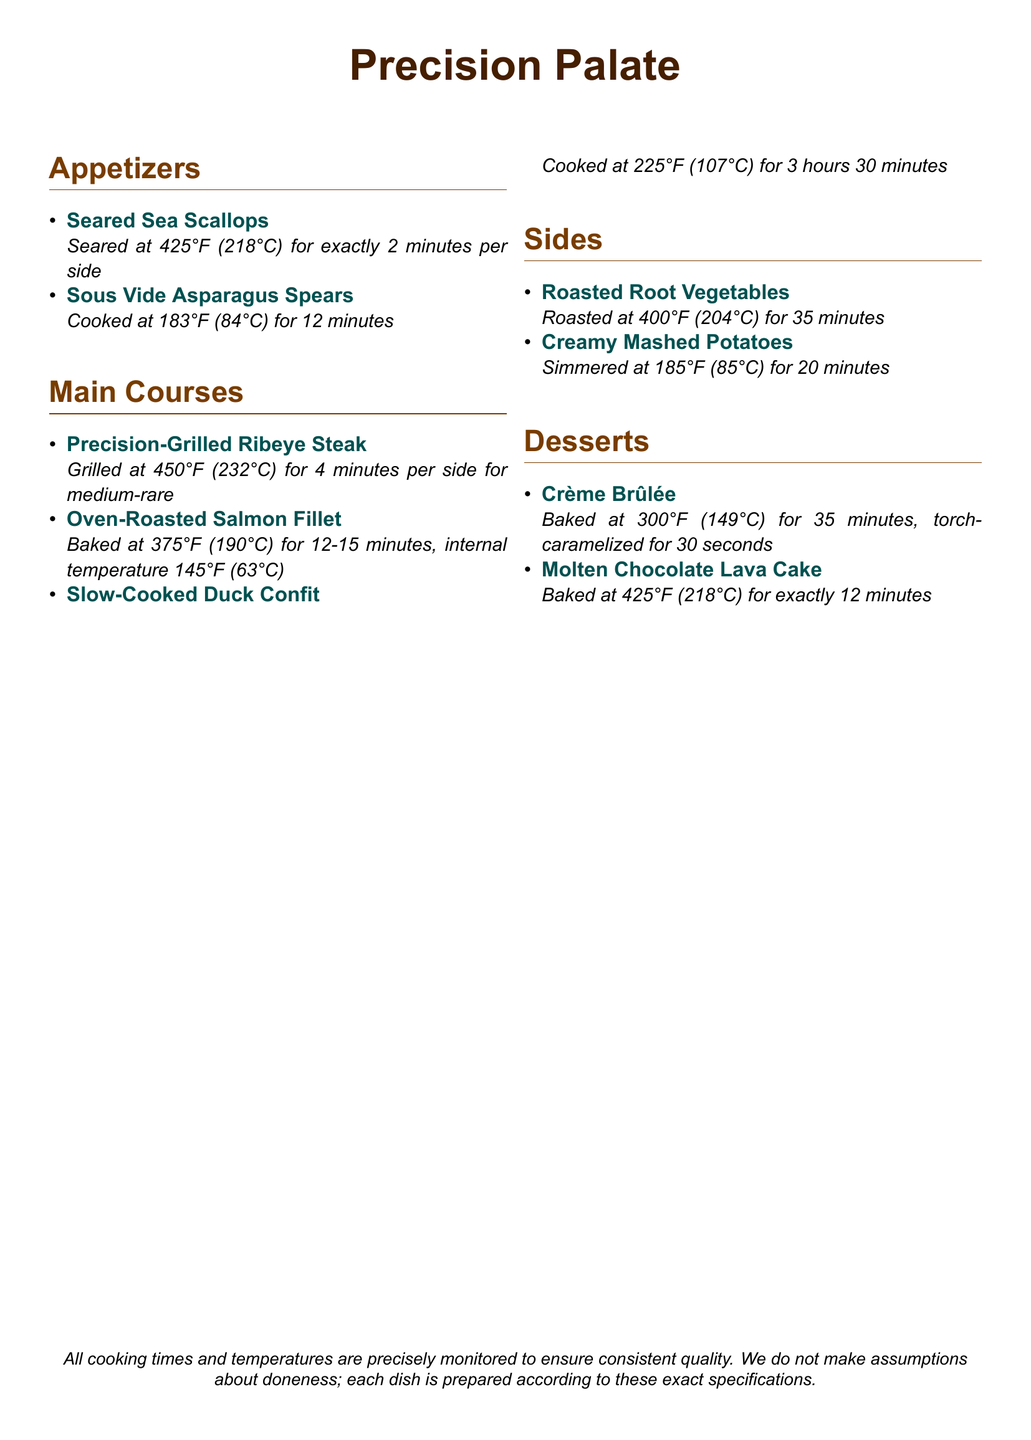What temperature are the sea scallops seared at? The temperature for searing sea scallops is specified in the document as 425°F (218°C).
Answer: 425°F (218°C) How long is the duck confit cooked? The cooking time for duck confit is detailed in the document, which mentions it is cooked for 3 hours 30 minutes.
Answer: 3 hours 30 minutes What is the internal temperature for the salmon fillet? The document states that the internal temperature for the salmon fillet should reach 145°F (63°C).
Answer: 145°F (63°C) Which dish has the longest cooking time? By comparing the cooking times provided, duck confit has the longest cooking time at 3 hours 30 minutes.
Answer: Duck Confit How long should the crème brûlée be baked? The baking duration for crème brûlée is specified in the document as 35 minutes.
Answer: 35 minutes What is the method used to cook asparagus spears? The document specifies that asparagus spears are cooked using the sous vide method.
Answer: Sous vide What is the cooking temperature for roasted root vegetables? The document indicates that roasted root vegetables are roasted at 400°F (204°C).
Answer: 400°F (204°C) How are the scallops prepared if not specified? The document emphasizes that cooking times and temperatures are closely monitored, implying all instructions must be followed exactly.
Answer: Not specified 